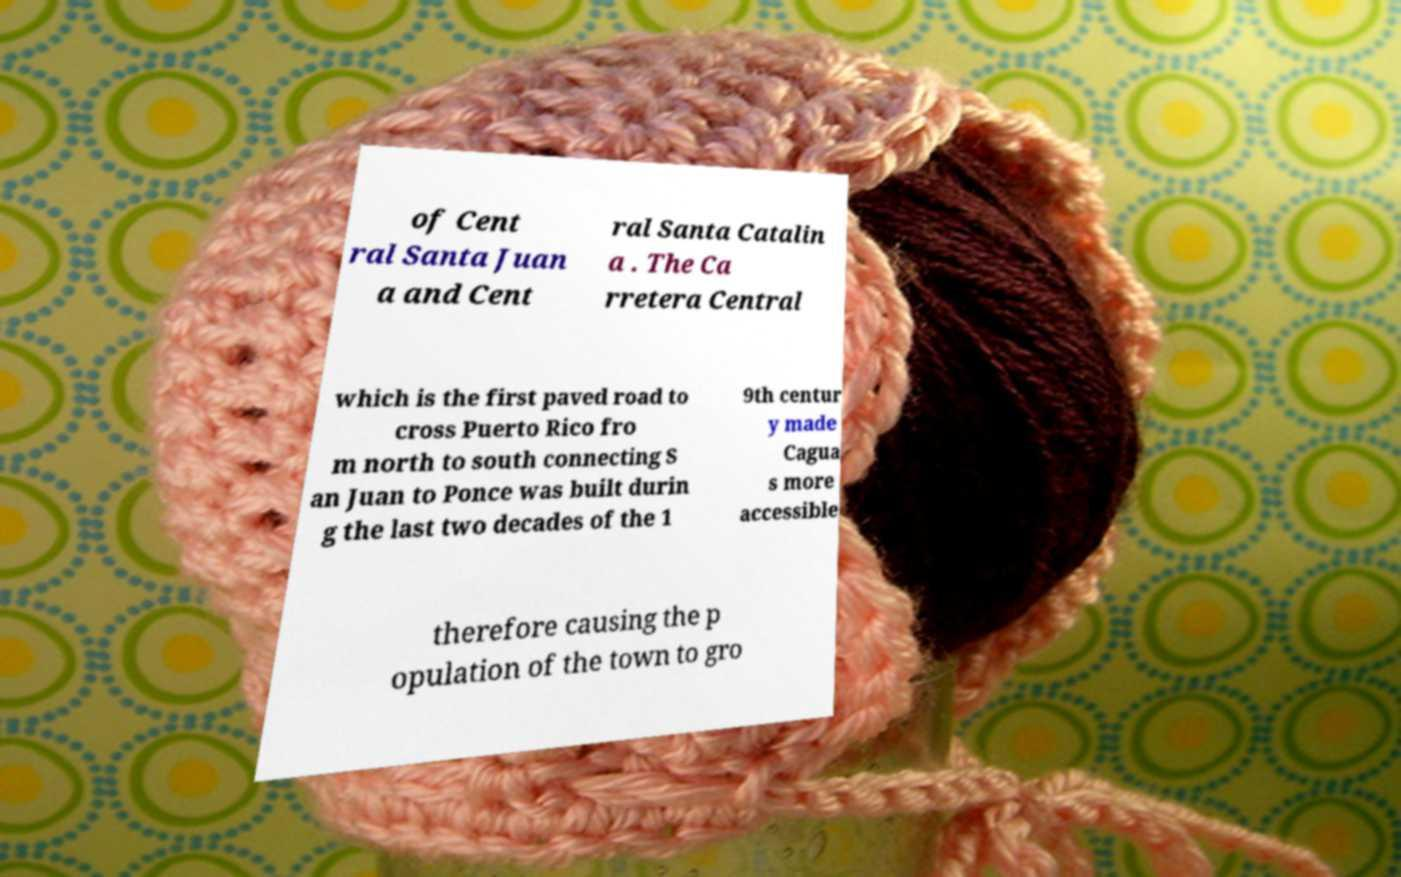There's text embedded in this image that I need extracted. Can you transcribe it verbatim? of Cent ral Santa Juan a and Cent ral Santa Catalin a . The Ca rretera Central which is the first paved road to cross Puerto Rico fro m north to south connecting S an Juan to Ponce was built durin g the last two decades of the 1 9th centur y made Cagua s more accessible therefore causing the p opulation of the town to gro 